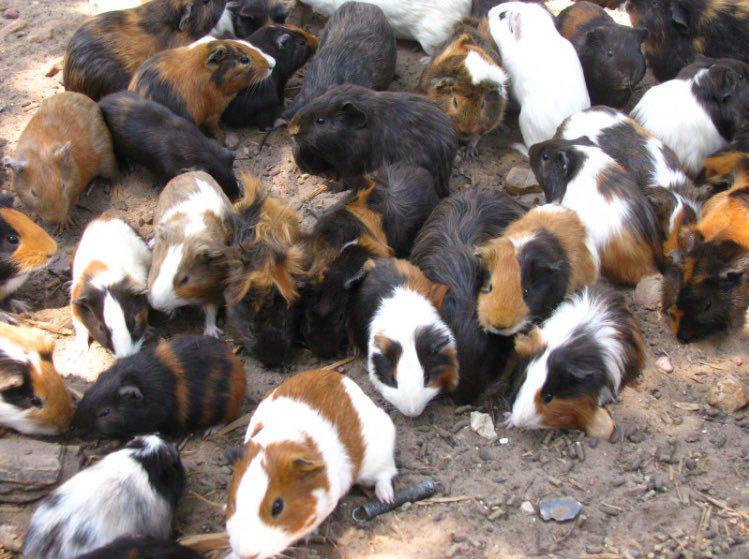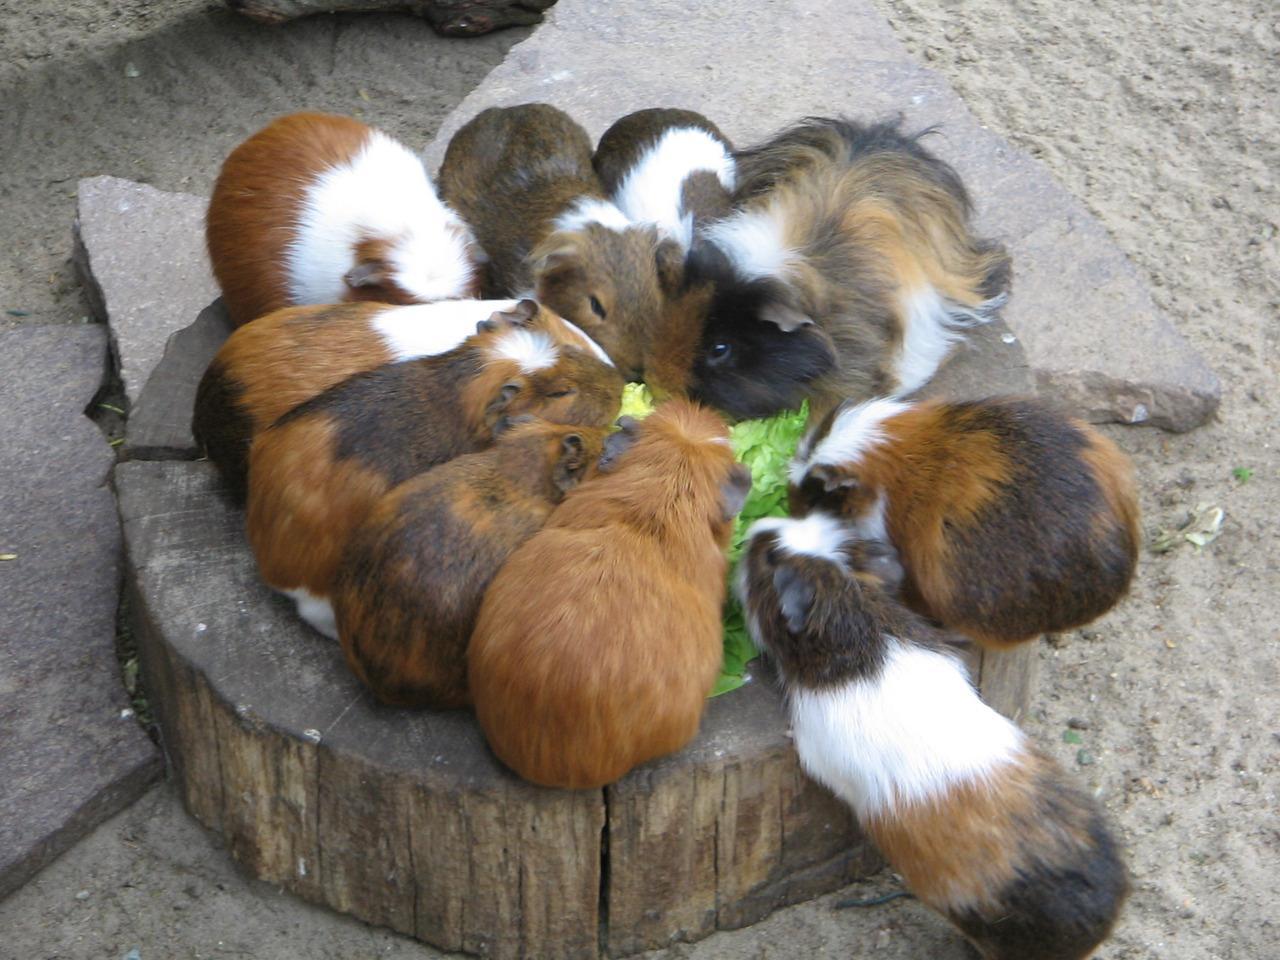The first image is the image on the left, the second image is the image on the right. Considering the images on both sides, is "Guinea pigs are clustered around a pile of vegetables in one photo." valid? Answer yes or no. Yes. 